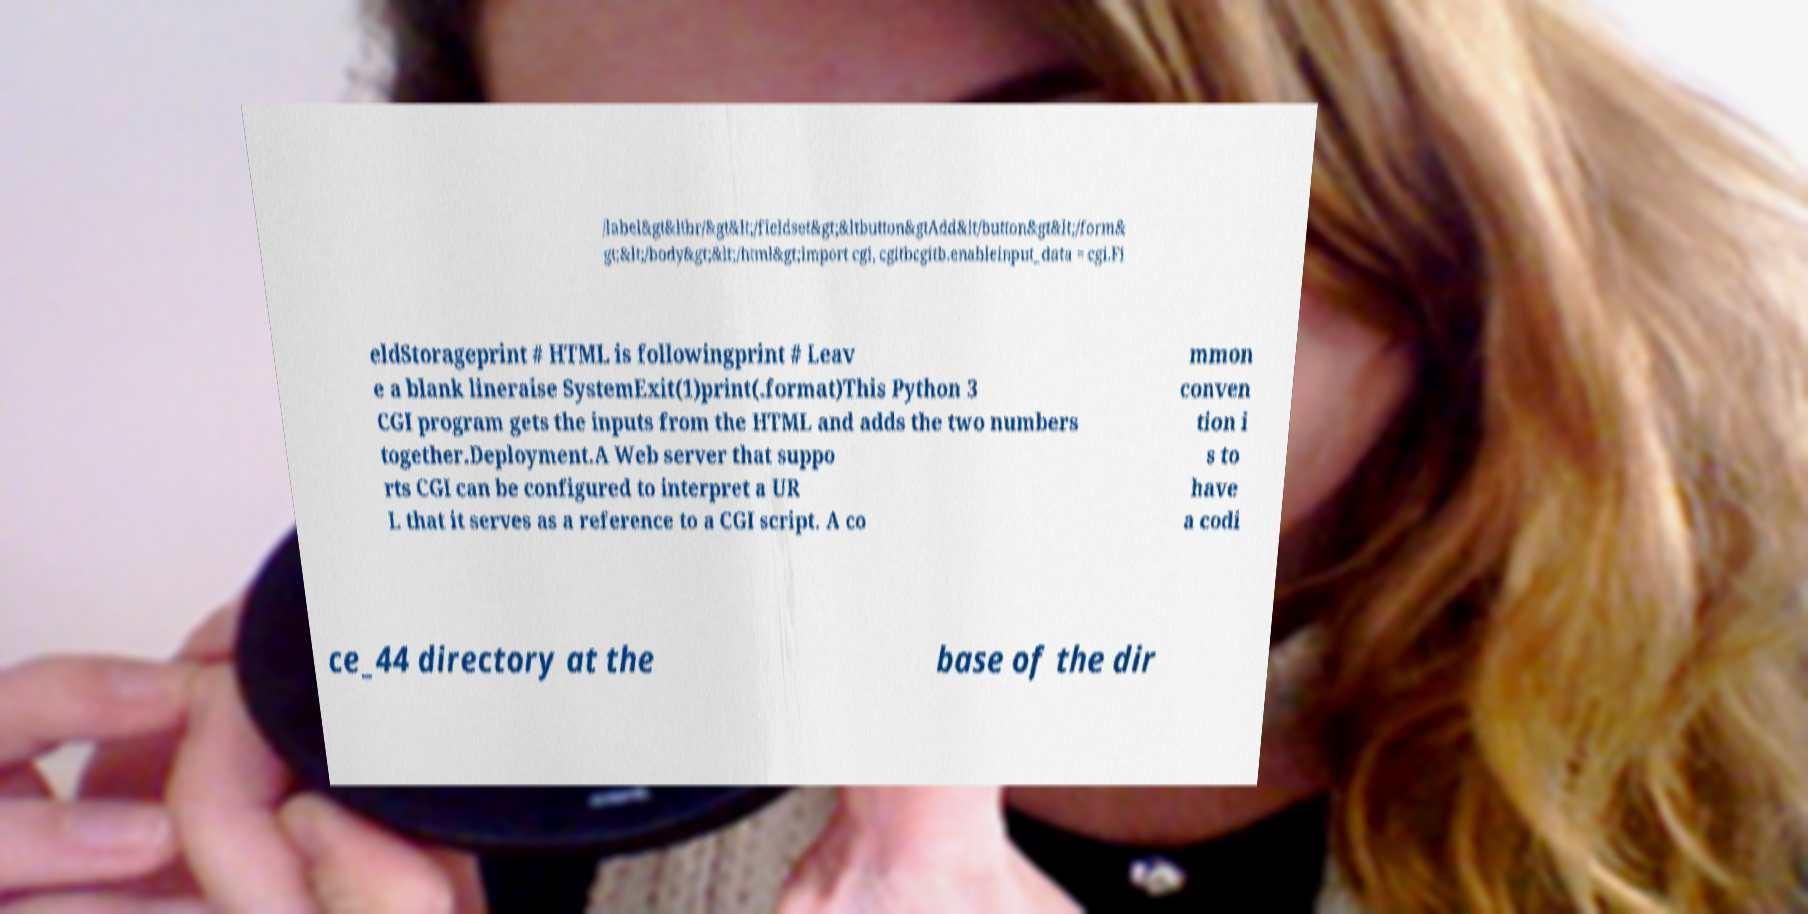Please identify and transcribe the text found in this image. /label&gt&ltbr/&gt&lt;/fieldset&gt;&ltbutton&gtAdd&lt/button&gt&lt;/form& gt;&lt;/body&gt;&lt;/html&gt;import cgi, cgitbcgitb.enableinput_data = cgi.Fi eldStorageprint # HTML is followingprint # Leav e a blank lineraise SystemExit(1)print(.format)This Python 3 CGI program gets the inputs from the HTML and adds the two numbers together.Deployment.A Web server that suppo rts CGI can be configured to interpret a UR L that it serves as a reference to a CGI script. A co mmon conven tion i s to have a codi ce_44 directory at the base of the dir 